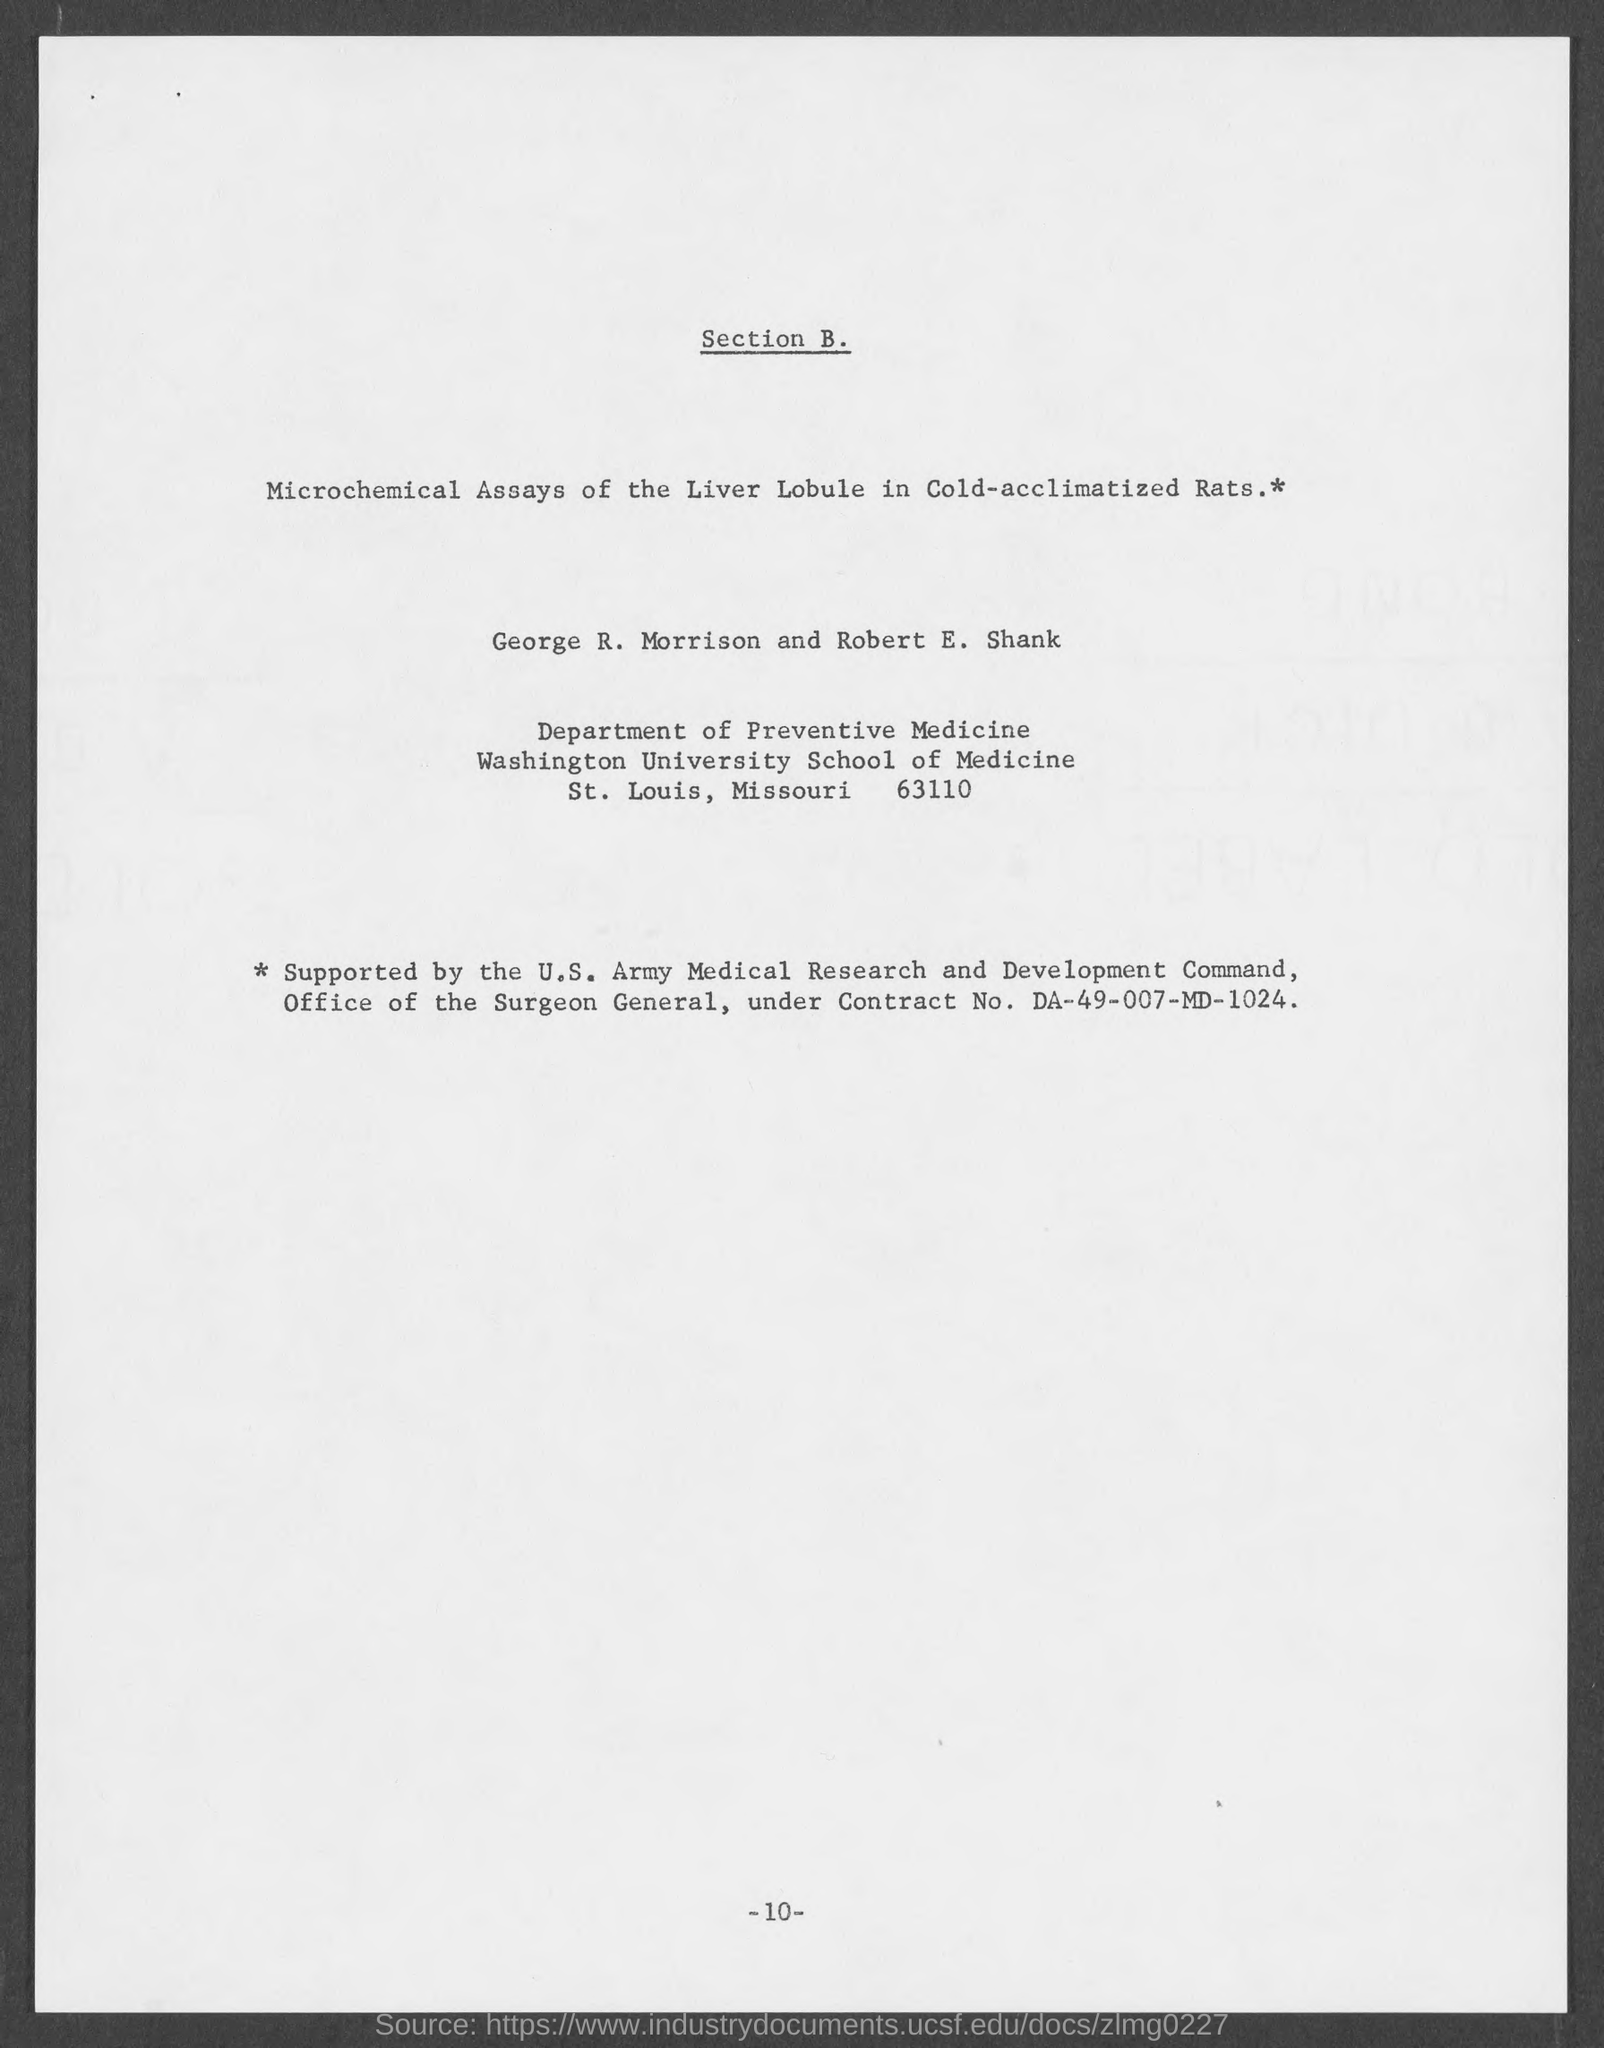Give some essential details in this illustration. What is Contract No. DA-49-007-MD-1024?" is a question asking for information about a contract. The document mentions the Department of Preventive Medicine. 